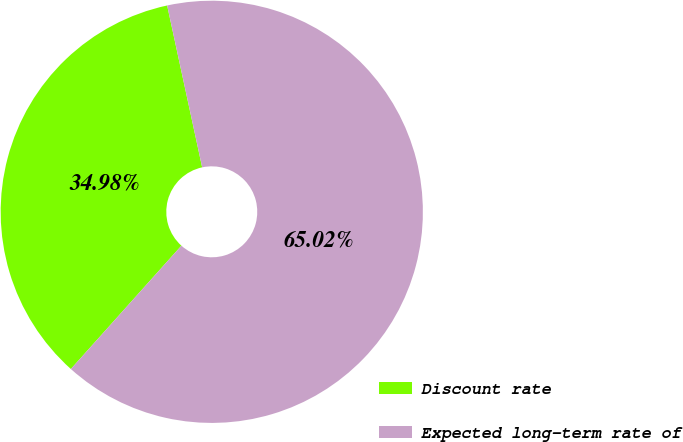Convert chart to OTSL. <chart><loc_0><loc_0><loc_500><loc_500><pie_chart><fcel>Discount rate<fcel>Expected long-term rate of<nl><fcel>34.98%<fcel>65.02%<nl></chart> 